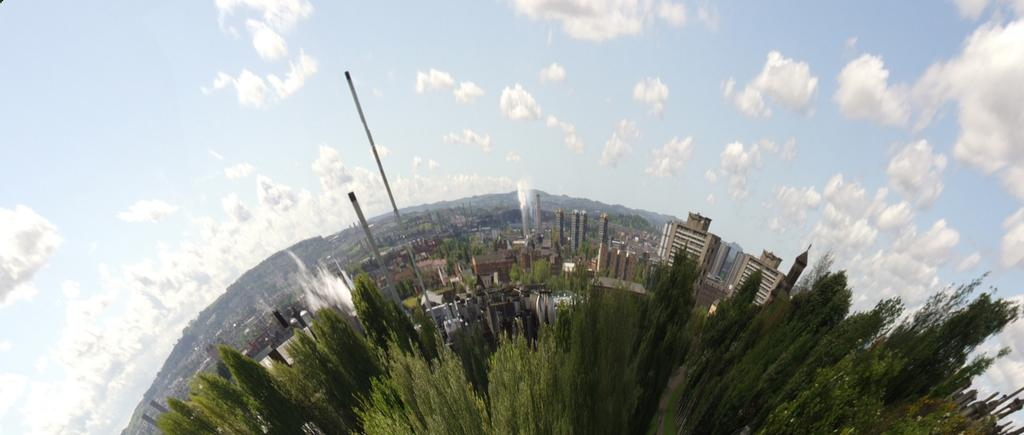What type of natural elements can be seen in the image? There are trees in the image. What type of man-made structures are visible in the image? There are buildings in the image. What other objects can be seen in the image? There are poles in the image. What is visible in the background of the image? The sky is visible in the image. What can be observed in the sky? Clouds are present in the sky. What type of government is depicted in the image? There is no depiction of a government in the image; it features trees, buildings, poles, and clouds. What book is the person reading in the image? There is no person reading a book in the image; it does not contain any reading material or individuals. 